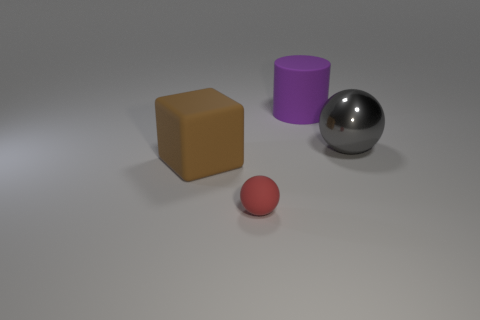Subtract 1 blocks. How many blocks are left? 0 Subtract all red balls. How many balls are left? 1 Add 4 large green blocks. How many objects exist? 8 Add 2 big cyan spheres. How many big cyan spheres exist? 2 Subtract 0 cyan cylinders. How many objects are left? 4 Subtract all green blocks. Subtract all yellow cylinders. How many blocks are left? 1 Subtract all red blocks. How many red cylinders are left? 0 Subtract all small red objects. Subtract all red shiny blocks. How many objects are left? 3 Add 4 big spheres. How many big spheres are left? 5 